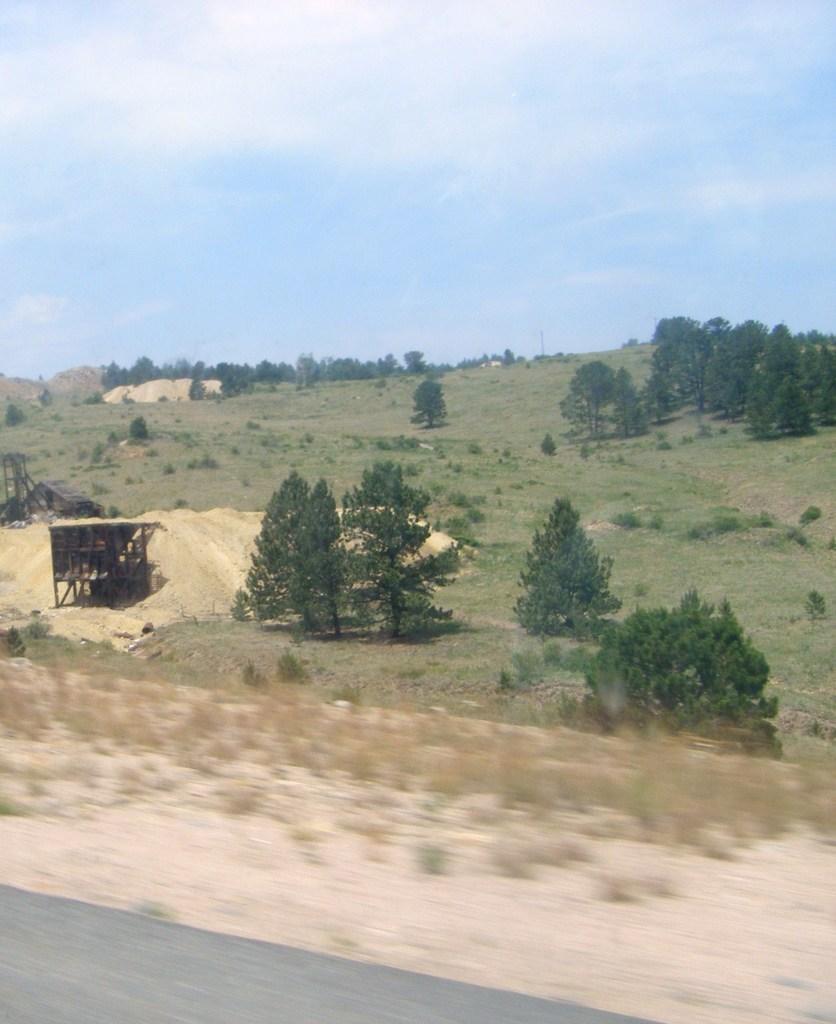In one or two sentences, can you explain what this image depicts? In this image at the bottom there is walkway, sand and some plants. And in the background there are some trees, grass, plants and some sheds. At the top of the image there is sky. 